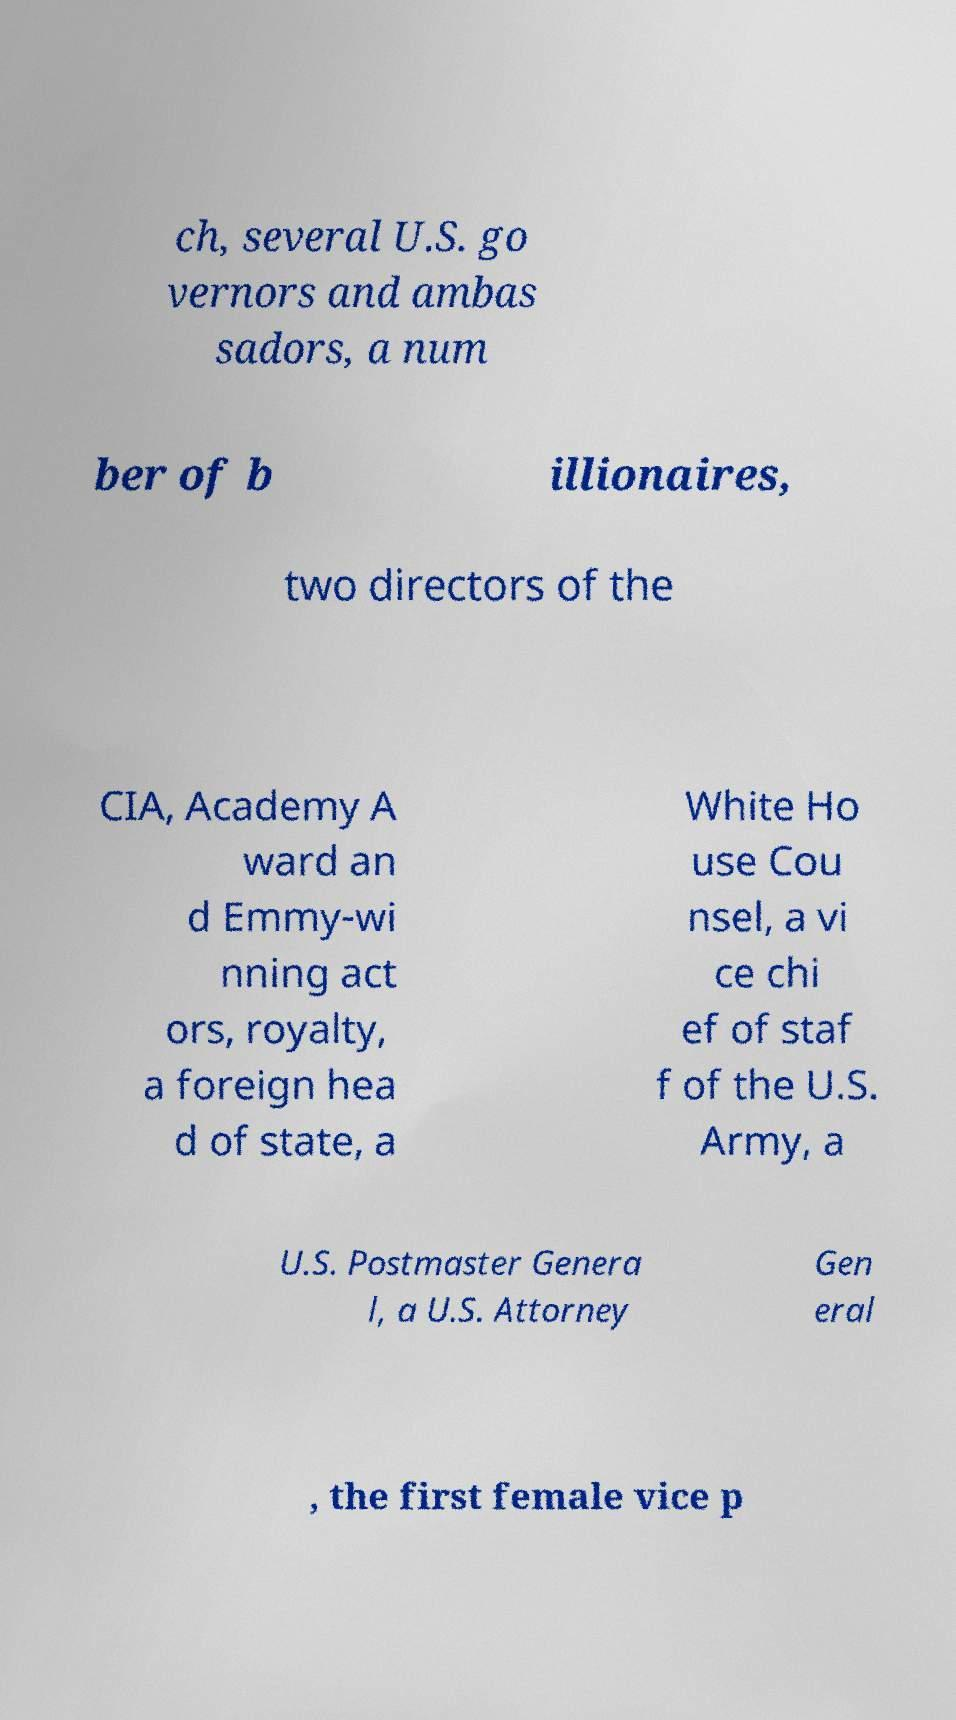Please read and relay the text visible in this image. What does it say? ch, several U.S. go vernors and ambas sadors, a num ber of b illionaires, two directors of the CIA, Academy A ward an d Emmy-wi nning act ors, royalty, a foreign hea d of state, a White Ho use Cou nsel, a vi ce chi ef of staf f of the U.S. Army, a U.S. Postmaster Genera l, a U.S. Attorney Gen eral , the first female vice p 